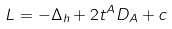Convert formula to latex. <formula><loc_0><loc_0><loc_500><loc_500>L = - \Delta _ { h } + 2 t ^ { A } D _ { A } + c</formula> 